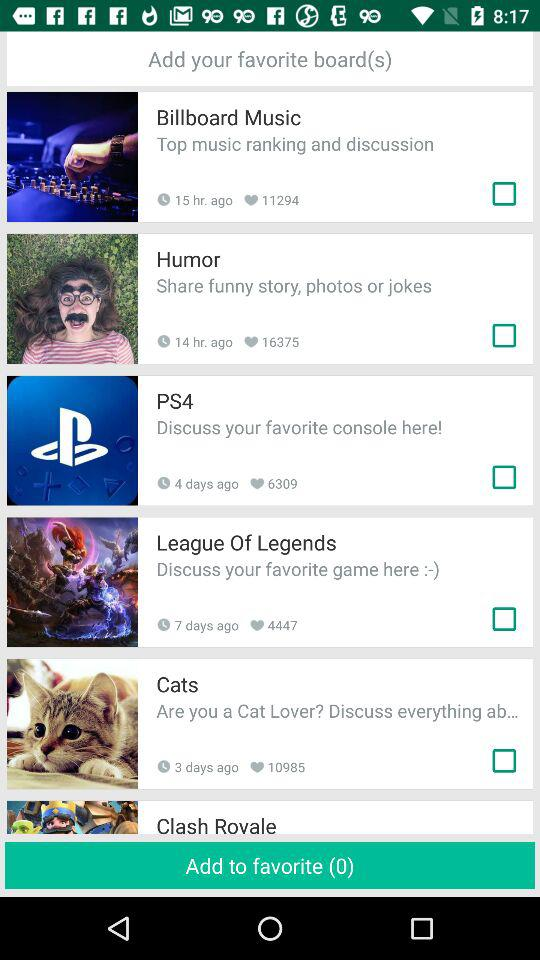How many heart likes are there of "Billboard Music"? There are 11294 heart likes of "Billboard Music". 